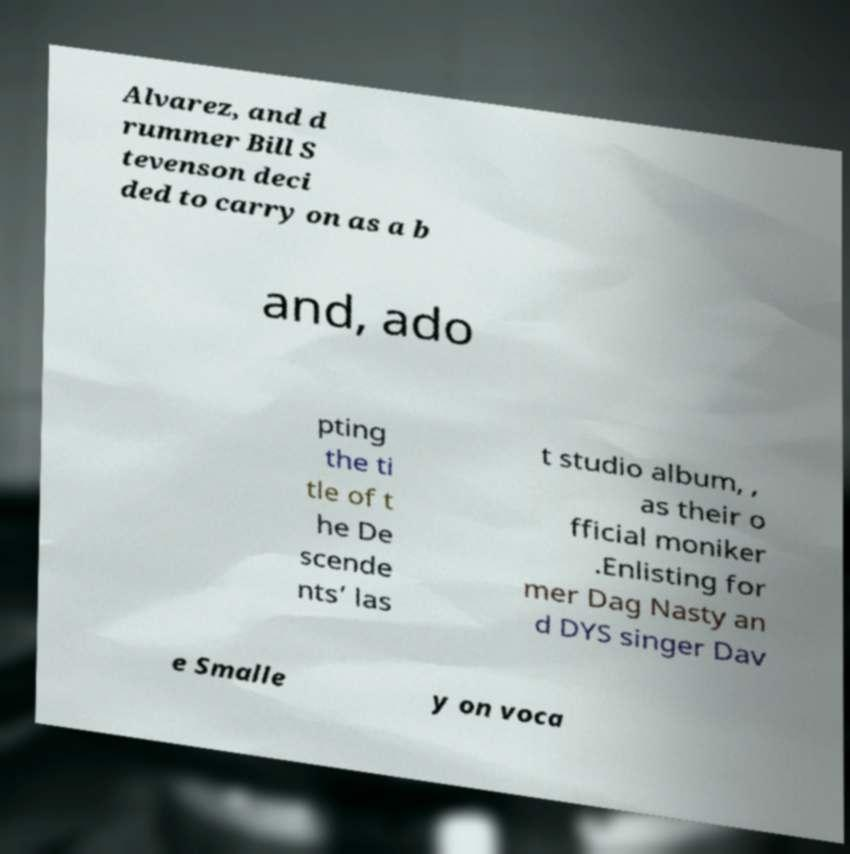Can you read and provide the text displayed in the image?This photo seems to have some interesting text. Can you extract and type it out for me? Alvarez, and d rummer Bill S tevenson deci ded to carry on as a b and, ado pting the ti tle of t he De scende nts’ las t studio album, , as their o fficial moniker .Enlisting for mer Dag Nasty an d DYS singer Dav e Smalle y on voca 